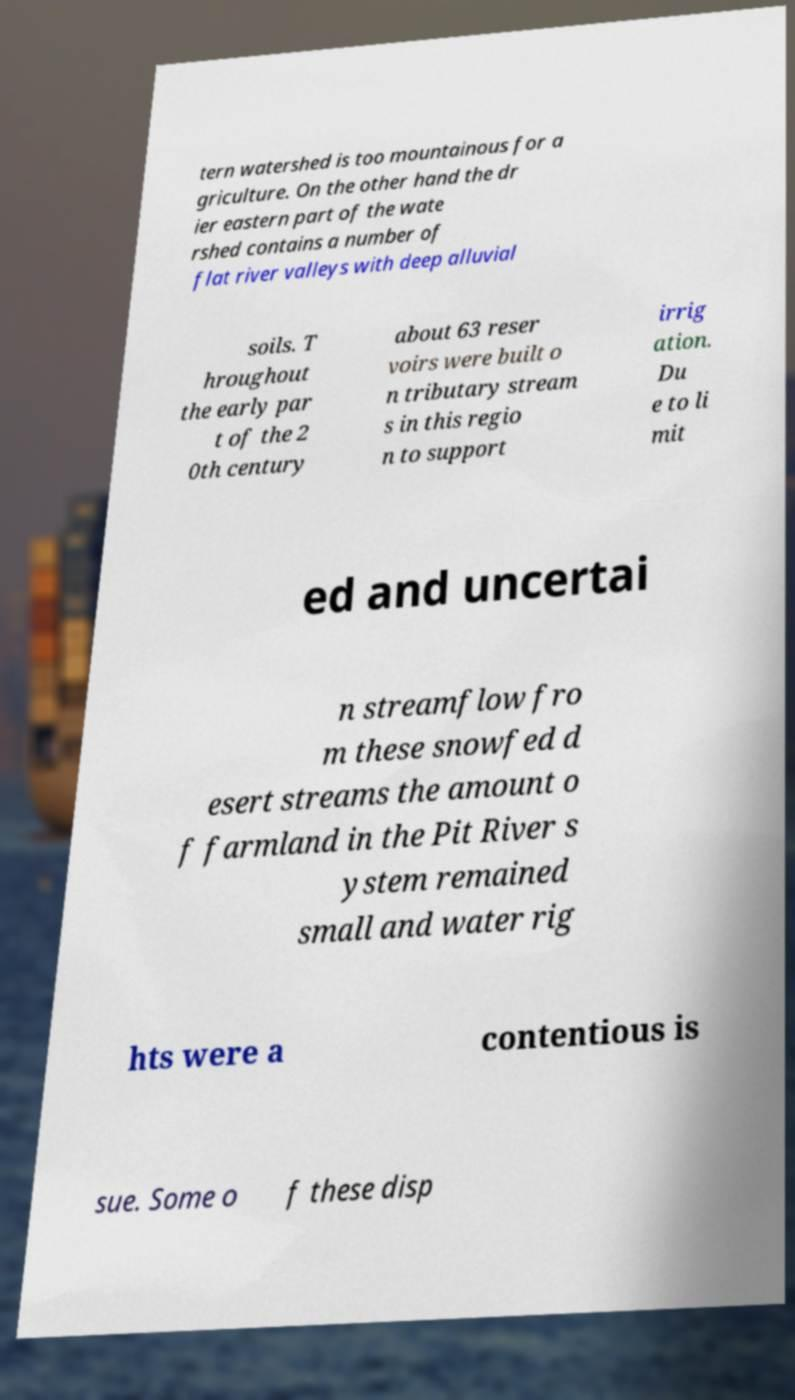For documentation purposes, I need the text within this image transcribed. Could you provide that? tern watershed is too mountainous for a griculture. On the other hand the dr ier eastern part of the wate rshed contains a number of flat river valleys with deep alluvial soils. T hroughout the early par t of the 2 0th century about 63 reser voirs were built o n tributary stream s in this regio n to support irrig ation. Du e to li mit ed and uncertai n streamflow fro m these snowfed d esert streams the amount o f farmland in the Pit River s ystem remained small and water rig hts were a contentious is sue. Some o f these disp 